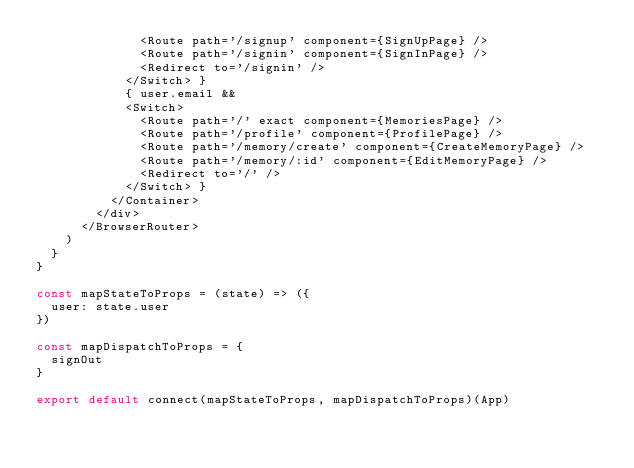<code> <loc_0><loc_0><loc_500><loc_500><_JavaScript_>              <Route path='/signup' component={SignUpPage} />
              <Route path='/signin' component={SignInPage} />
              <Redirect to='/signin' />
            </Switch> }
            { user.email &&
            <Switch>
              <Route path='/' exact component={MemoriesPage} />
              <Route path='/profile' component={ProfilePage} />
              <Route path='/memory/create' component={CreateMemoryPage} />
              <Route path='/memory/:id' component={EditMemoryPage} />
              <Redirect to='/' />
            </Switch> }
          </Container>
        </div>
      </BrowserRouter>
    )
  }
}

const mapStateToProps = (state) => ({
  user: state.user
})

const mapDispatchToProps = {
  signOut
}

export default connect(mapStateToProps, mapDispatchToProps)(App)
</code> 